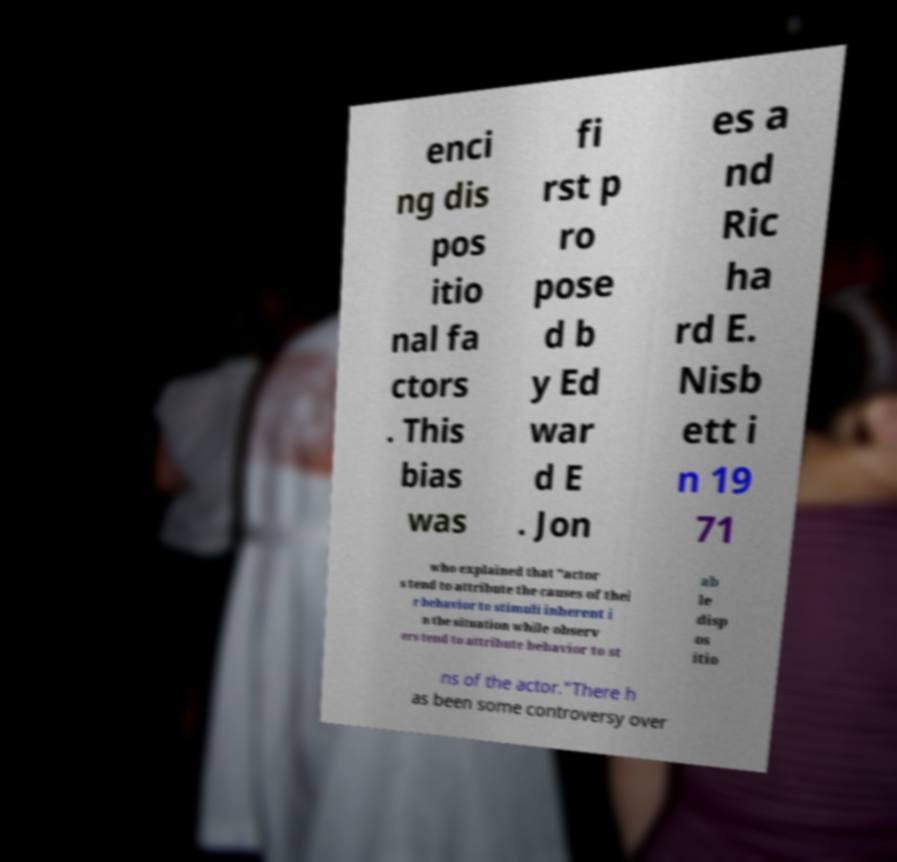Could you assist in decoding the text presented in this image and type it out clearly? enci ng dis pos itio nal fa ctors . This bias was fi rst p ro pose d b y Ed war d E . Jon es a nd Ric ha rd E. Nisb ett i n 19 71 who explained that "actor s tend to attribute the causes of thei r behavior to stimuli inherent i n the situation while observ ers tend to attribute behavior to st ab le disp os itio ns of the actor."There h as been some controversy over 